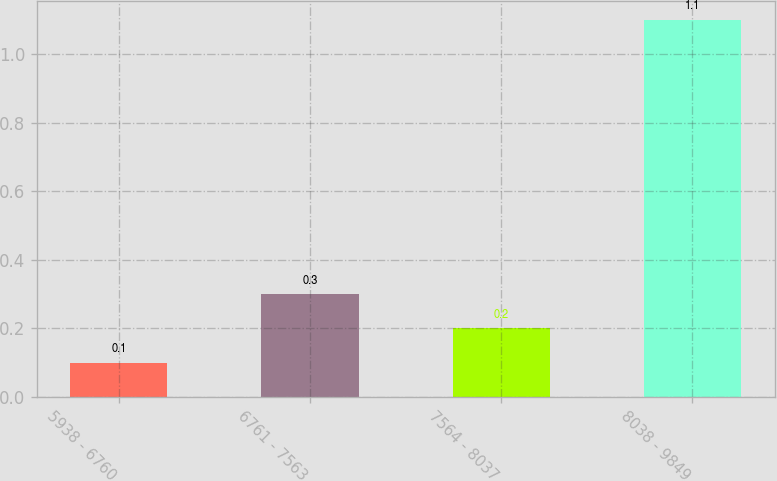Convert chart. <chart><loc_0><loc_0><loc_500><loc_500><bar_chart><fcel>5938 - 6760<fcel>6761 - 7563<fcel>7564 - 8037<fcel>8038 - 9849<nl><fcel>0.1<fcel>0.3<fcel>0.2<fcel>1.1<nl></chart> 